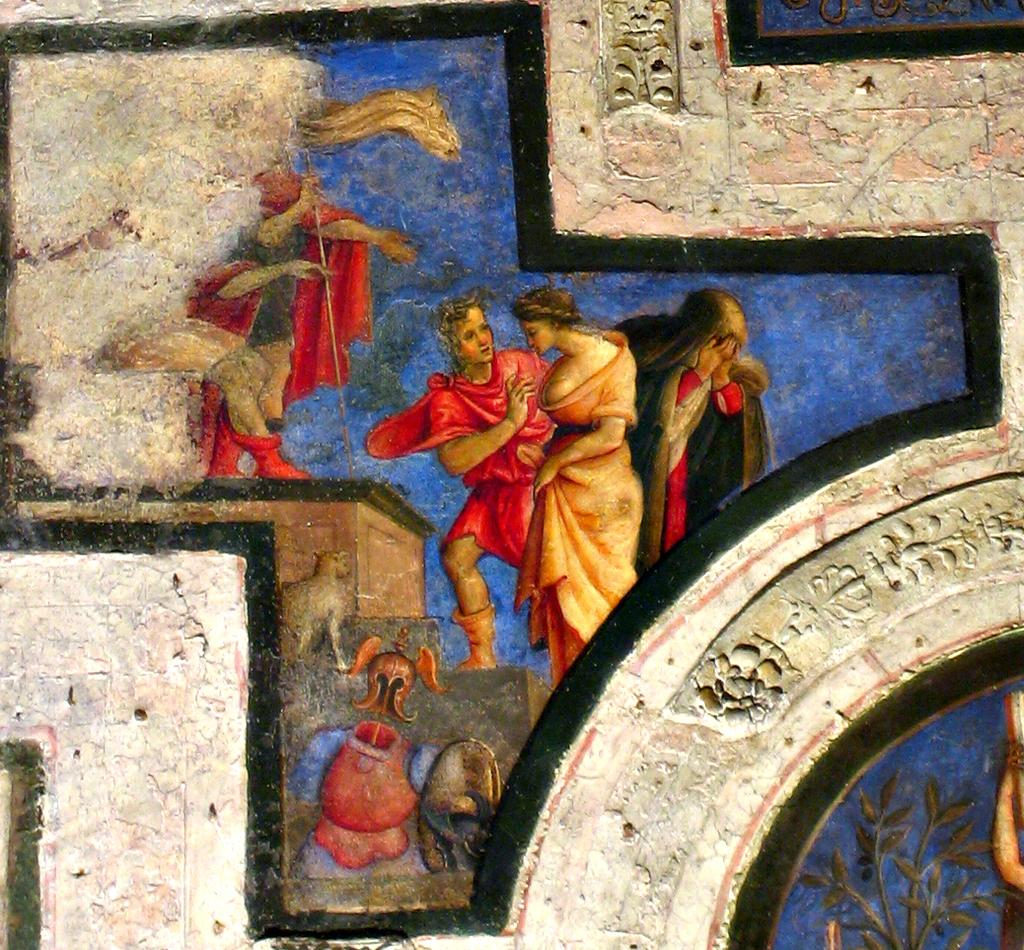What is the main subject of the image? There is a painting in the image. What does the painting depict? The painting depicts a group of people. What other object can be seen in the image besides the painting? There is a plant in the image. What is present on the wall in the image? There are objects on the wall in the image. How many feet are visible in the painting? There are no feet visible in the painting, as the image only shows a painting of a group of people and not the actual people themselves. 